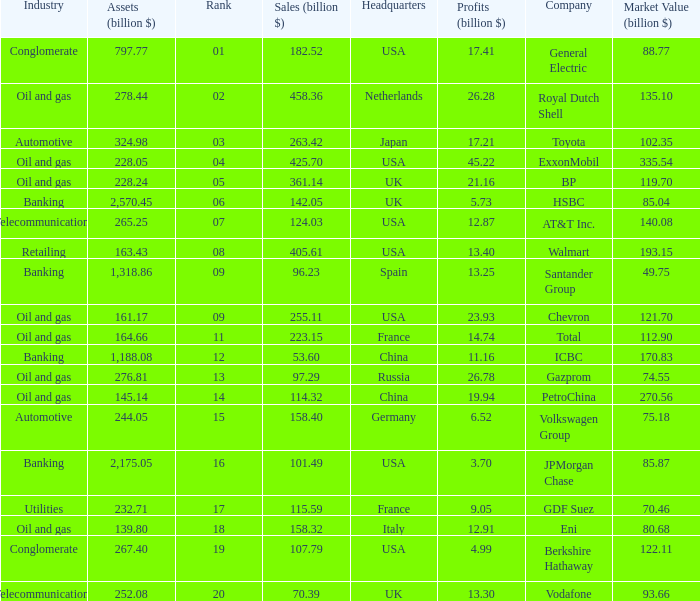Name the lowest Market Value (billion $) which has Assets (billion $) larger than 276.81, and a Company of toyota, and Profits (billion $) larger than 17.21? None. 